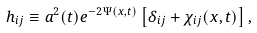<formula> <loc_0><loc_0><loc_500><loc_500>h _ { i j } \equiv a ^ { 2 } ( t ) e ^ { - 2 \Psi ( { x } , t ) } \left [ \delta _ { i j } + \chi _ { i j } ( { x } , t ) \right ] ,</formula> 